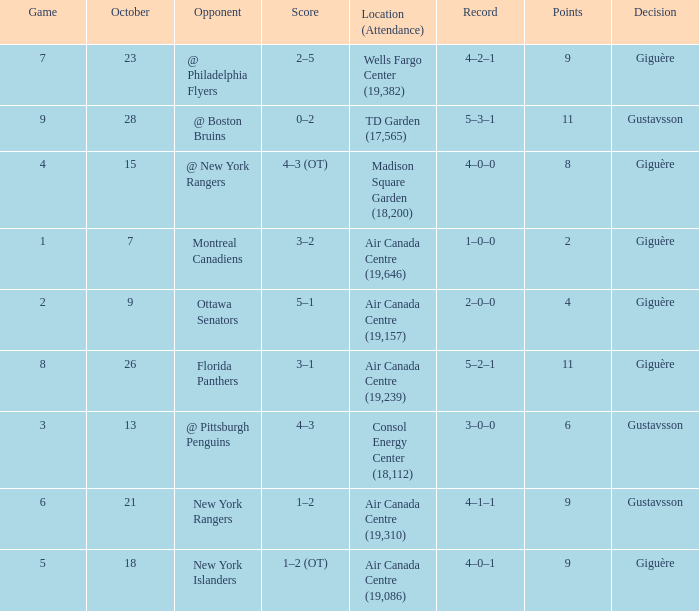What was the score for the opponent florida panthers? 1.0. 